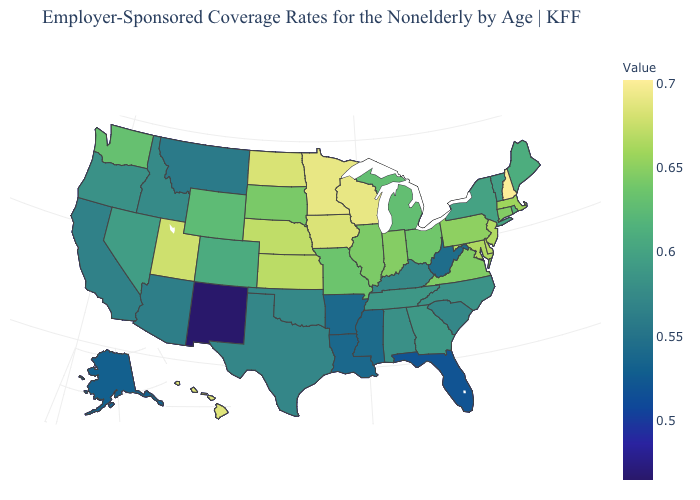Does New Hampshire have the highest value in the Northeast?
Short answer required. Yes. Among the states that border New Hampshire , does Vermont have the lowest value?
Give a very brief answer. Yes. Among the states that border Georgia , does Tennessee have the highest value?
Short answer required. Yes. Does Washington have the lowest value in the West?
Quick response, please. No. 